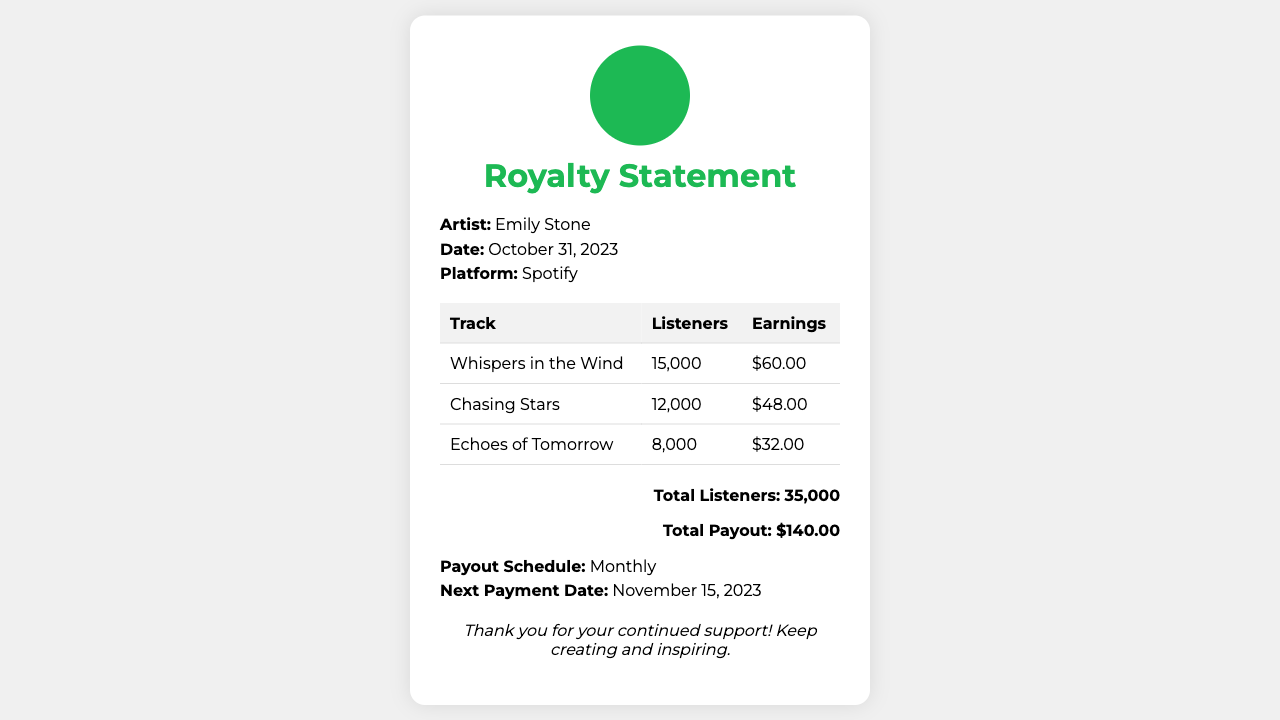What is the artist's name? The document states that the artist is Emily Stone.
Answer: Emily Stone What is the total number of listeners? The total listeners are calculated by adding the listeners from all tracks listed in the table, which is 15,000 + 12,000 + 8,000.
Answer: 35,000 When is the next payment date? The document mentions that the next payment date is November 15, 2023.
Answer: November 15, 2023 How much did "Chasing Stars" earn? The earnings for "Chasing Stars" are listed as $48.00 in the document.
Answer: $48.00 What is the total payout amount? The total payout is stated at the end of the document as $140.00, which sums the earnings of all tracks.
Answer: $140.00 What platform is this statement for? The document indicates that this royalty statement is from Spotify.
Answer: Spotify How many tracks are listed in the statement? The document features three tracks listed in the earnings table.
Answer: 3 What is the payout schedule? The document specifies the payout schedule as monthly.
Answer: Monthly 